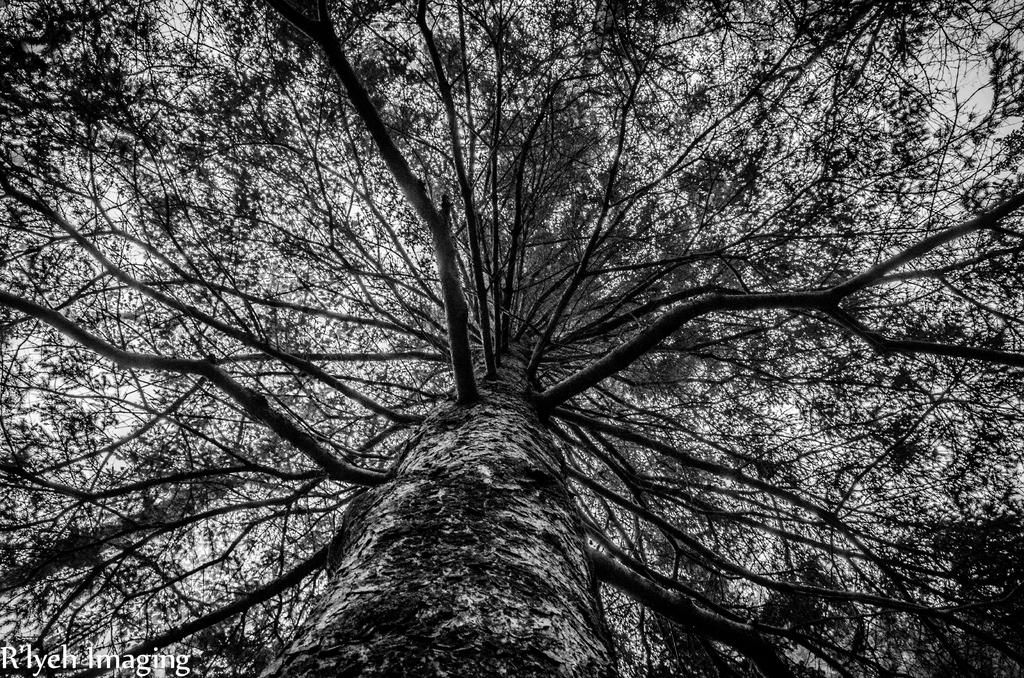What is the main object in the picture? There is a tree in the picture. Can you describe the tree in more detail? The tree has many branches. What can be seen at the top of the image? The sky is visible at the top of the image. Where is the text located in the image? The text is in the bottom left corner of the image. How many deer are visible in the image? There are no deer present in the image; it features a tree with many branches and text in the bottom left corner. What type of authority is depicted in the image? There is no depiction of authority in the image; it only shows a tree, the sky, and text. 